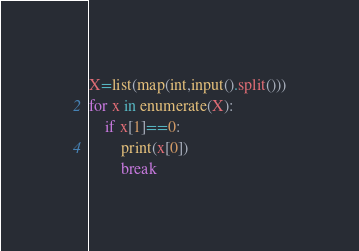Convert code to text. <code><loc_0><loc_0><loc_500><loc_500><_Python_>X=list(map(int,input().split()))
for x in enumerate(X):
    if x[1]==0:
        print(x[0])
        break</code> 